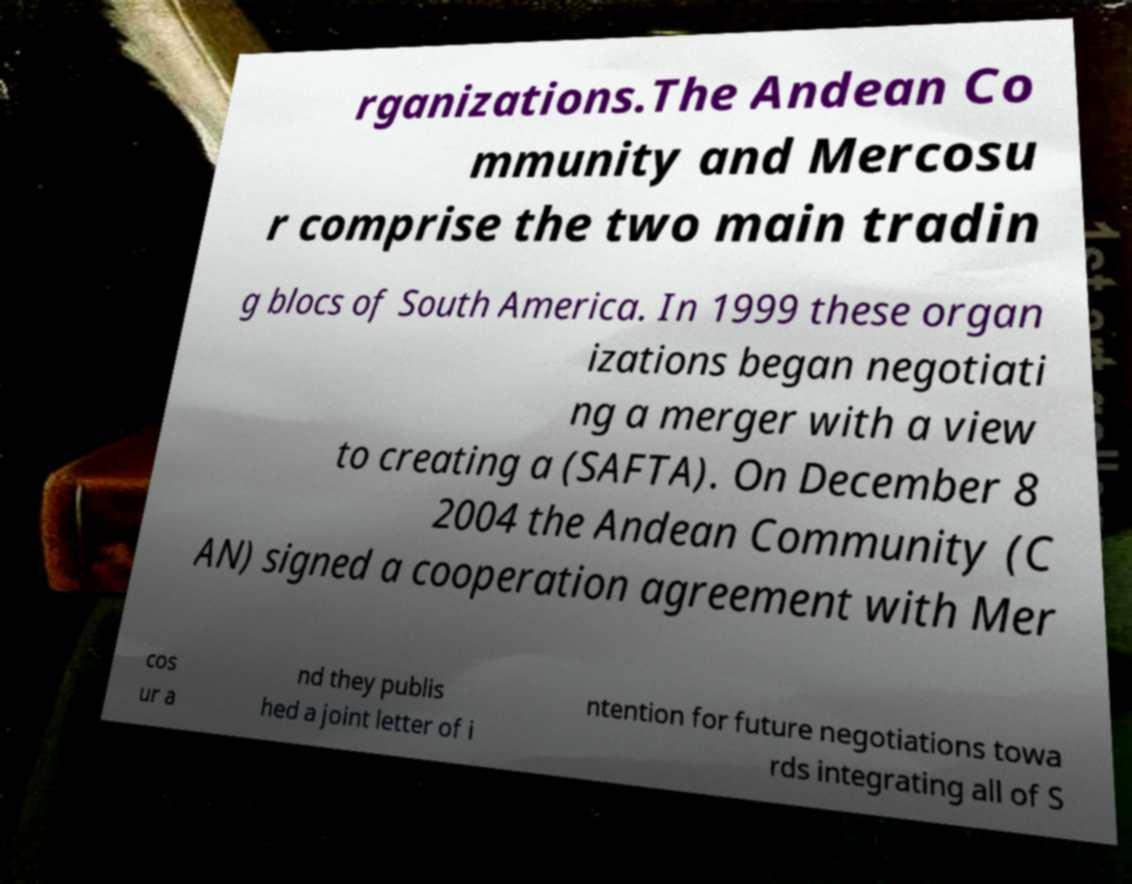There's text embedded in this image that I need extracted. Can you transcribe it verbatim? rganizations.The Andean Co mmunity and Mercosu r comprise the two main tradin g blocs of South America. In 1999 these organ izations began negotiati ng a merger with a view to creating a (SAFTA). On December 8 2004 the Andean Community (C AN) signed a cooperation agreement with Mer cos ur a nd they publis hed a joint letter of i ntention for future negotiations towa rds integrating all of S 